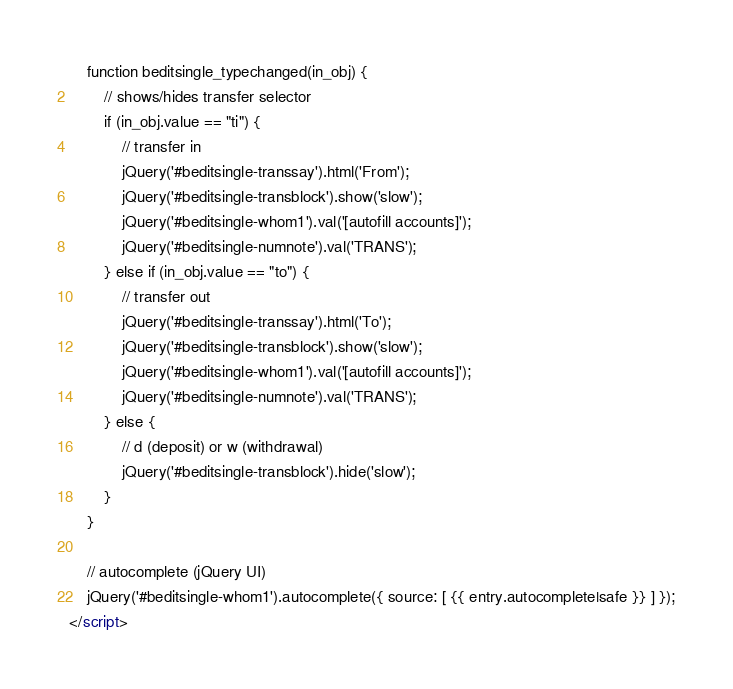<code> <loc_0><loc_0><loc_500><loc_500><_HTML_>    function beditsingle_typechanged(in_obj) {
        // shows/hides transfer selector
        if (in_obj.value == "ti") {
            // transfer in
            jQuery('#beditsingle-transsay').html('From');
            jQuery('#beditsingle-transblock').show('slow');
            jQuery('#beditsingle-whom1').val('[autofill accounts]');
            jQuery('#beditsingle-numnote').val('TRANS');
        } else if (in_obj.value == "to") {
            // transfer out
            jQuery('#beditsingle-transsay').html('To');
            jQuery('#beditsingle-transblock').show('slow');
            jQuery('#beditsingle-whom1').val('[autofill accounts]');
            jQuery('#beditsingle-numnote').val('TRANS');
        } else {
            // d (deposit) or w (withdrawal)
            jQuery('#beditsingle-transblock').hide('slow');
        }
    }

    // autocomplete (jQuery UI)
    jQuery('#beditsingle-whom1').autocomplete({ source: [ {{ entry.autocomplete|safe }} ] });
</script>
</code> 